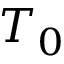Convert formula to latex. <formula><loc_0><loc_0><loc_500><loc_500>T _ { 0 }</formula> 